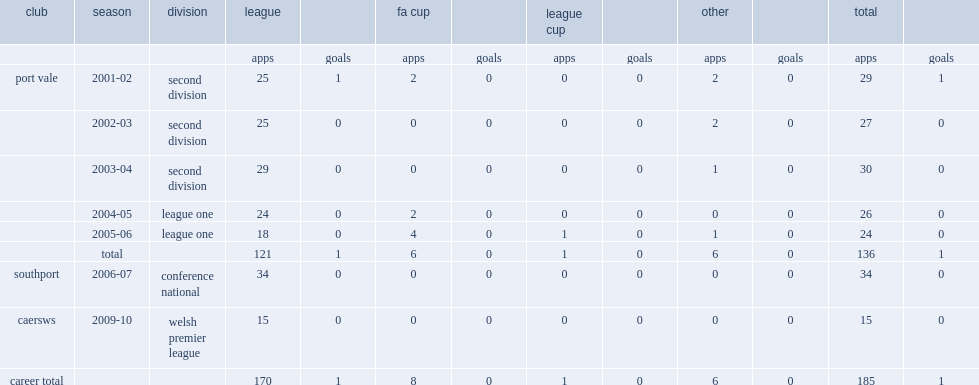Can you parse all the data within this table? {'header': ['club', 'season', 'division', 'league', '', 'fa cup', '', 'league cup', '', 'other', '', 'total', ''], 'rows': [['', '', '', 'apps', 'goals', 'apps', 'goals', 'apps', 'goals', 'apps', 'goals', 'apps', 'goals'], ['port vale', '2001-02', 'second division', '25', '1', '2', '0', '0', '0', '2', '0', '29', '1'], ['', '2002-03', 'second division', '25', '0', '0', '0', '0', '0', '2', '0', '27', '0'], ['', '2003-04', 'second division', '29', '0', '0', '0', '0', '0', '1', '0', '30', '0'], ['', '2004-05', 'league one', '24', '0', '2', '0', '0', '0', '0', '0', '26', '0'], ['', '2005-06', 'league one', '18', '0', '4', '0', '1', '0', '1', '0', '24', '0'], ['', 'total', '', '121', '1', '6', '0', '1', '0', '6', '0', '136', '1'], ['southport', '2006-07', 'conference national', '34', '0', '0', '0', '0', '0', '0', '0', '34', '0'], ['caersws', '2009-10', 'welsh premier league', '15', '0', '0', '0', '0', '0', '0', '0', '15', '0'], ['career total', '', '', '170', '1', '8', '0', '1', '0', '6', '0', '185', '1']]} How many league appearances did steve rowland make in the 2006-07 season for conference national side southport? 34.0. 